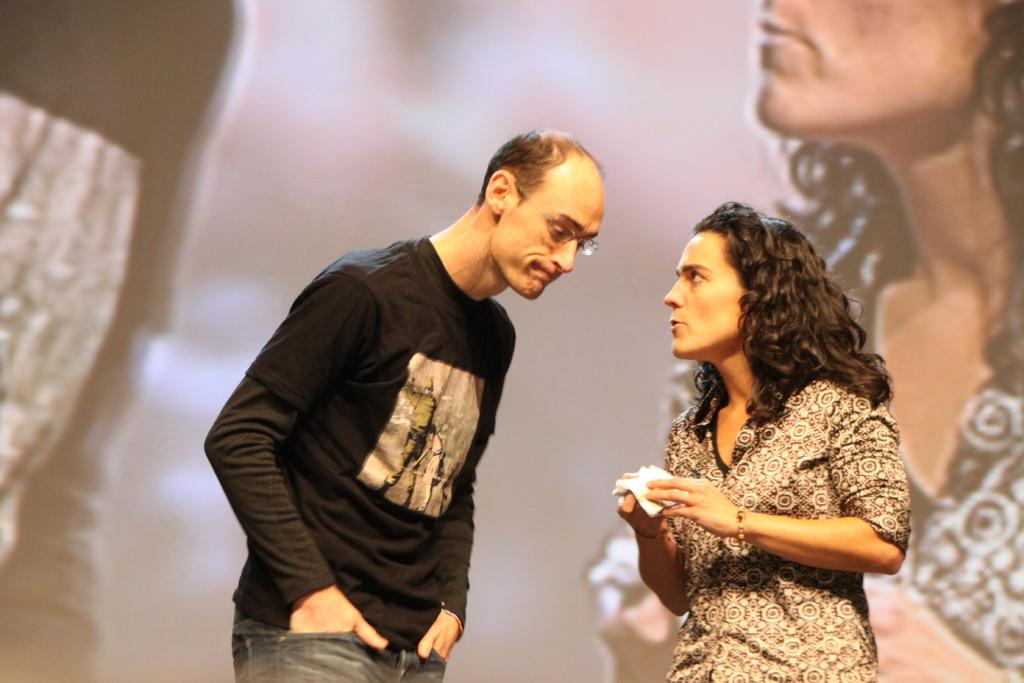Who is the main subject in the middle of the image? There is a man standing in the middle of the image. What is the man wearing in the image? The man is wearing a black t-shirt and jeans. Who is the other person in the image? There is a woman standing on the right side of the image. What is the woman doing in the image? The woman is speaking. What is the woman wearing in the image? The woman is wearing a shirt. What type of magic is the man performing in the image? There is no magic or any indication of magic being performed in the image. Can you see a boat in the image? There is no boat present in the image. 